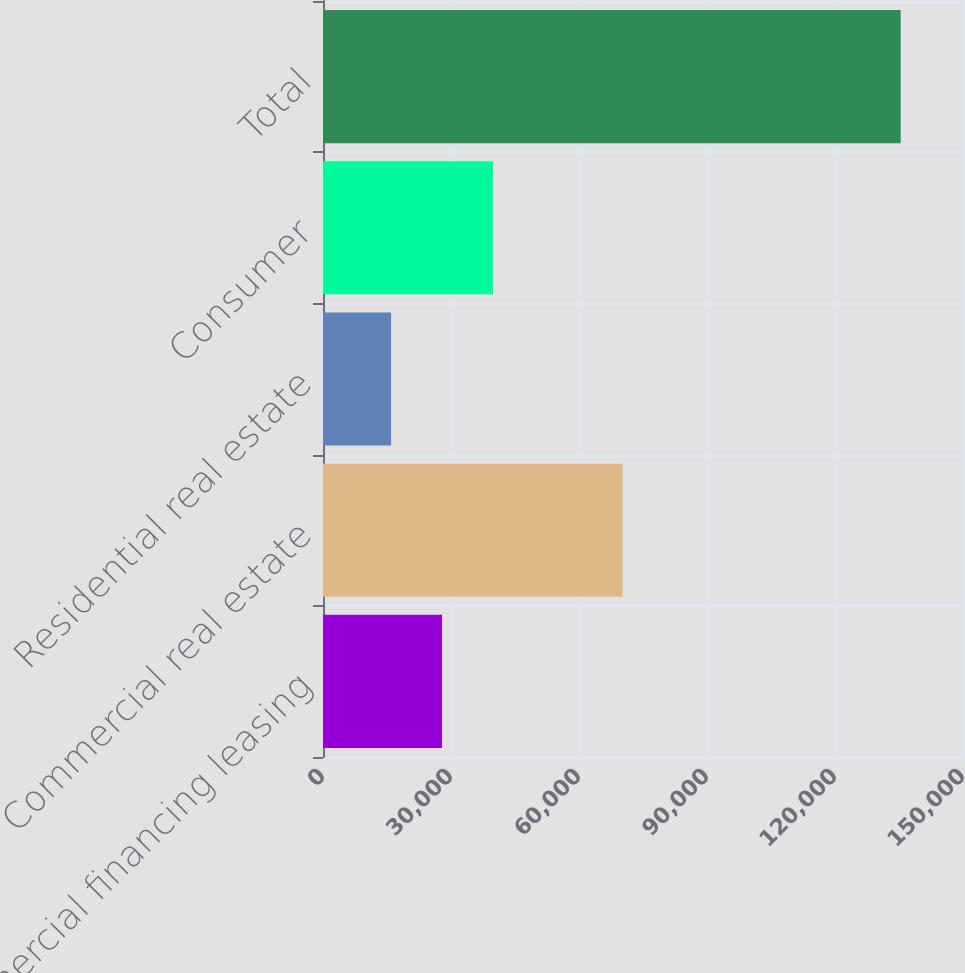<chart> <loc_0><loc_0><loc_500><loc_500><bar_chart><fcel>Commercial financing leasing<fcel>Commercial real estate<fcel>Residential real estate<fcel>Consumer<fcel>Total<nl><fcel>27901.2<fcel>70261<fcel>15958<fcel>39844.4<fcel>135390<nl></chart> 